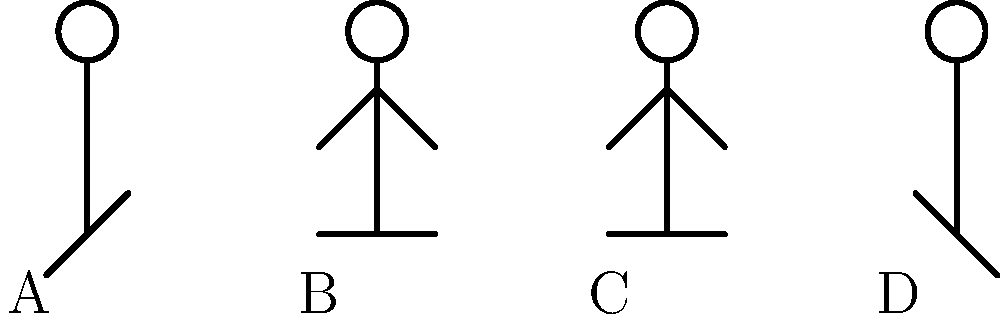As a community counselor, you're observing a group interaction. Which figure's body language suggests the most defensive or closed-off posture? To interpret body language in this scenario, we need to analyze each figure's posture:

1. Figure A: 
   - Arms are not visible
   - Legs are slightly apart
   - This posture appears neutral or slightly open

2. Figure B: 
   - Arms are visible and open
   - Legs are straight and together
   - This posture suggests an open and receptive stance

3. Figure C: 
   - Similar to Figure B, with open arms and straight legs
   - This also indicates an open and engaging posture

4. Figure D: 
   - Arms are not visible
   - Legs are crossed
   - This posture typically indicates a closed-off or defensive stance

In body language interpretation, crossed legs often signify a barrier or reluctance to engage. The absence of visible arms in Figure D could also suggest they are crossed or held close to the body, further reinforcing a closed-off impression.

Therefore, among the four figures, D exhibits the most defensive or closed-off body language.
Answer: D 